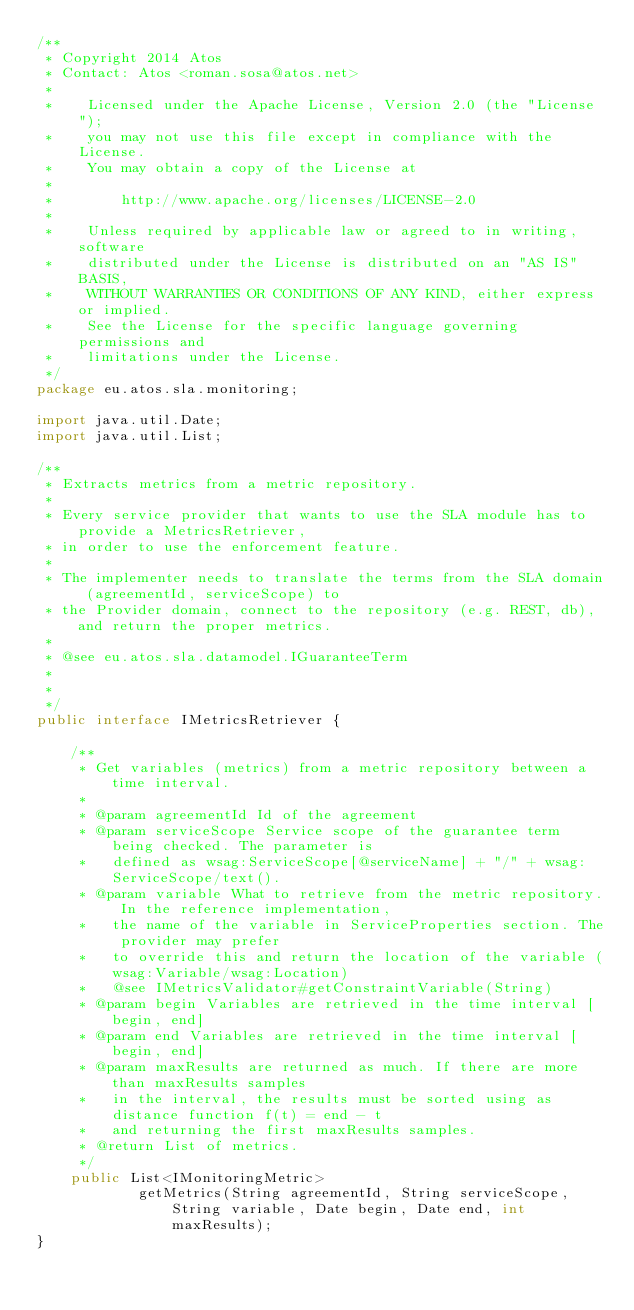<code> <loc_0><loc_0><loc_500><loc_500><_Java_>/**
 * Copyright 2014 Atos
 * Contact: Atos <roman.sosa@atos.net>
 *
 *    Licensed under the Apache License, Version 2.0 (the "License");
 *    you may not use this file except in compliance with the License.
 *    You may obtain a copy of the License at
 *
 *        http://www.apache.org/licenses/LICENSE-2.0
 *
 *    Unless required by applicable law or agreed to in writing, software
 *    distributed under the License is distributed on an "AS IS" BASIS,
 *    WITHOUT WARRANTIES OR CONDITIONS OF ANY KIND, either express or implied.
 *    See the License for the specific language governing permissions and
 *    limitations under the License.
 */
package eu.atos.sla.monitoring;

import java.util.Date;
import java.util.List;

/**
 * Extracts metrics from a metric repository.
 * 
 * Every service provider that wants to use the SLA module has to provide a MetricsRetriever, 
 * in order to use the enforcement feature. 
 * 
 * The implementer needs to translate the terms from the SLA domain (agreementId, serviceScope) to
 * the Provider domain, connect to the repository (e.g. REST, db), and return the proper metrics.
 *  
 * @see eu.atos.sla.datamodel.IGuaranteeTerm
 * 
 *
 */
public interface IMetricsRetriever {

    /**
     * Get variables (metrics) from a metric repository between a time interval.
     * 
     * @param agreementId Id of the agreement
     * @param serviceScope Service scope of the guarantee term being checked. The parameter is 
     *   defined as wsag:ServiceScope[@serviceName] + "/" + wsag:ServiceScope/text(). 
     * @param variable What to retrieve from the metric repository. In the reference implementation, 
     *   the name of the variable in ServiceProperties section. The provider may prefer
     *   to override this and return the location of the variable (wsag:Variable/wsag:Location)
     *   @see IMetricsValidator#getConstraintVariable(String)
     * @param begin Variables are retrieved in the time interval [begin, end]
     * @param end Variables are retrieved in the time interval [begin, end]
     * @param maxResults are returned as much. If there are more than maxResults samples
     *   in the interval, the results must be sorted using as distance function f(t) = end - t
     *   and returning the first maxResults samples. 
     * @return List of metrics.
     */
    public List<IMonitoringMetric> 
            getMetrics(String agreementId, String serviceScope, String variable, Date begin, Date end, int maxResults);
}
</code> 